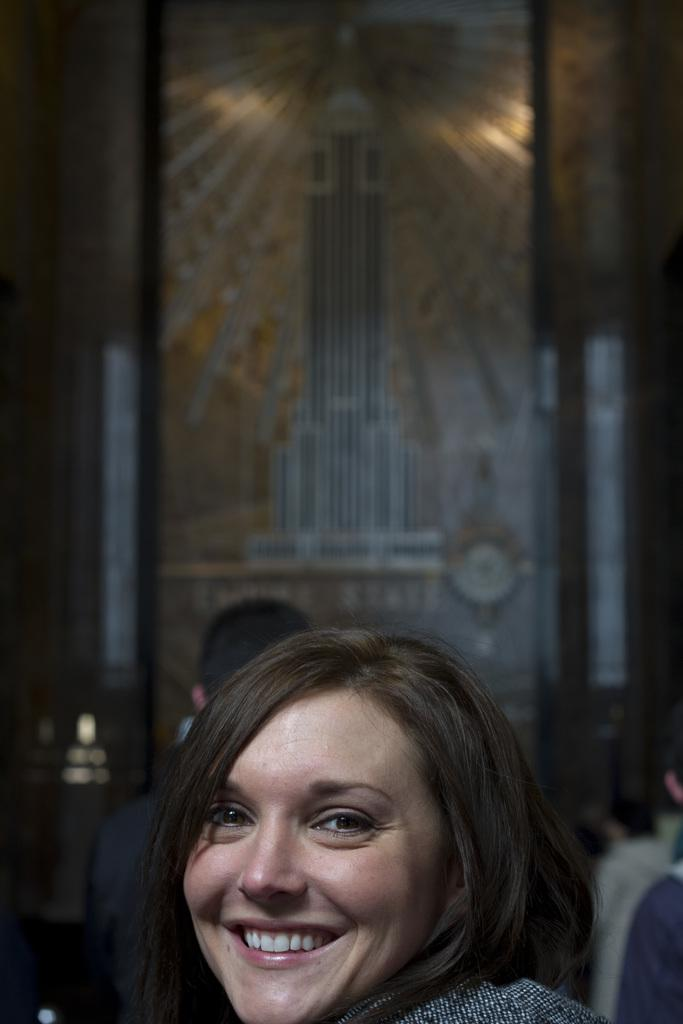Who is the main subject in the image? There is a woman in the image. Where is the woman located in relation to the image? The woman is in the foreground. What can be observed about the background of the image? The background of the woman is blurred. What type of wall can be seen in the background of the image? There is no wall visible in the background of the image; it is blurred. 